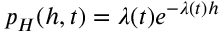Convert formula to latex. <formula><loc_0><loc_0><loc_500><loc_500>p _ { H } ( h , t ) = \lambda ( t ) e ^ { - \lambda ( t ) h }</formula> 